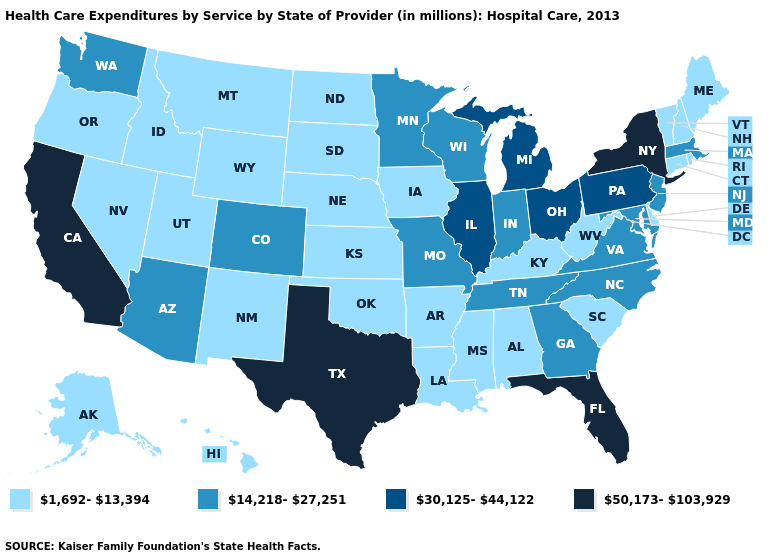What is the highest value in states that border Louisiana?
Short answer required. 50,173-103,929. Does the first symbol in the legend represent the smallest category?
Concise answer only. Yes. Which states have the lowest value in the USA?
Write a very short answer. Alabama, Alaska, Arkansas, Connecticut, Delaware, Hawaii, Idaho, Iowa, Kansas, Kentucky, Louisiana, Maine, Mississippi, Montana, Nebraska, Nevada, New Hampshire, New Mexico, North Dakota, Oklahoma, Oregon, Rhode Island, South Carolina, South Dakota, Utah, Vermont, West Virginia, Wyoming. Is the legend a continuous bar?
Be succinct. No. Which states hav the highest value in the Northeast?
Answer briefly. New York. Does the map have missing data?
Concise answer only. No. What is the value of Oklahoma?
Short answer required. 1,692-13,394. Does New York have the highest value in the USA?
Quick response, please. Yes. Which states hav the highest value in the South?
Concise answer only. Florida, Texas. What is the lowest value in the West?
Give a very brief answer. 1,692-13,394. What is the value of Alaska?
Answer briefly. 1,692-13,394. What is the value of Oklahoma?
Keep it brief. 1,692-13,394. What is the lowest value in the MidWest?
Concise answer only. 1,692-13,394. Which states have the highest value in the USA?
Be succinct. California, Florida, New York, Texas. 